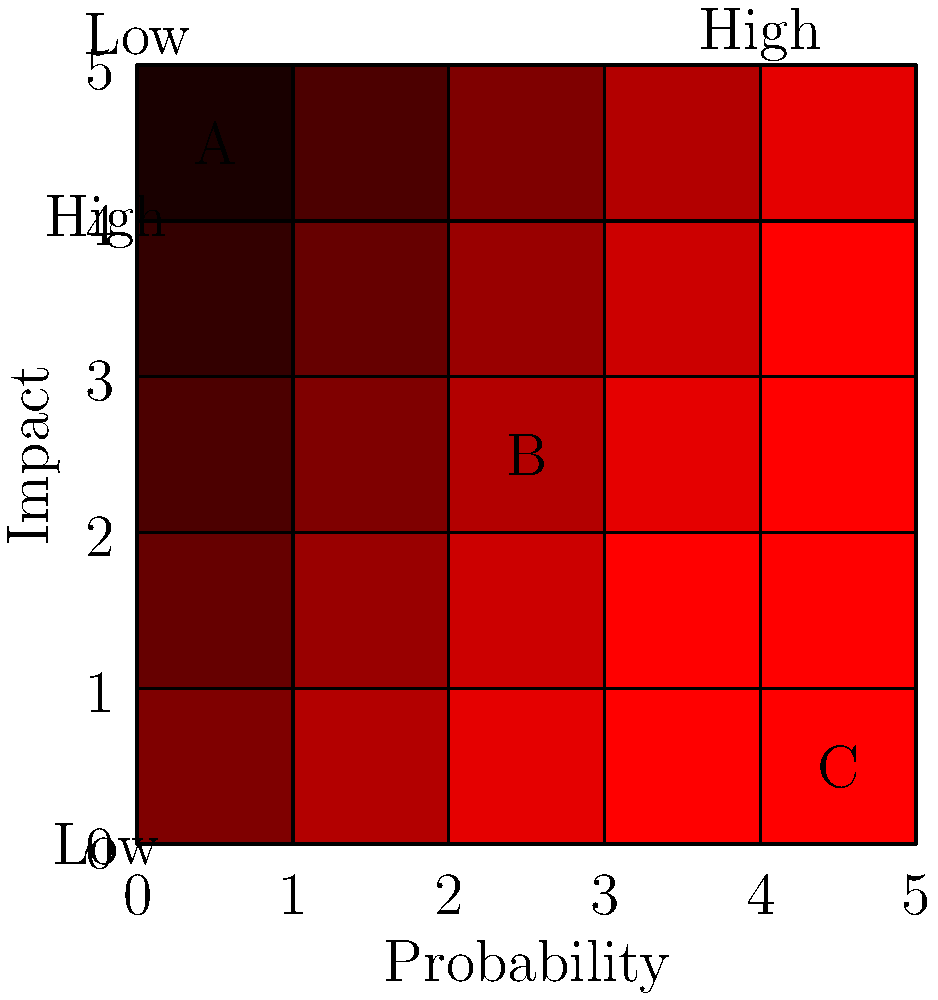As a project manager, you've been tasked with evaluating potential risks and opportunities for a new cost-effective solution. Given the risk matrix above, which of the identified items (A, B, or C) should be prioritized for immediate action to ensure project success without compromising performance? To evaluate the risk matrix and prioritize potential project threats and opportunities, we need to follow these steps:

1. Understand the matrix: The x-axis represents probability (increasing from left to right), and the y-axis represents impact (increasing from bottom to top).

2. Identify the color coding: The darker red areas indicate higher risk or higher priority opportunities.

3. Locate the positions of A, B, and C:
   A: High impact, low probability
   B: Medium impact, medium probability
   C: Low impact, high probability

4. Evaluate each item:
   A: High impact but low probability suggests a significant threat/opportunity that's unlikely to occur.
   B: Medium impact and probability indicate a moderate risk/opportunity.
   C: High probability but low impact suggests a likely event with minimal consequences.

5. Consider the business owner's perspective: As a cost-effective solution is desired without compromising performance, we should prioritize items that could significantly impact the project's success or failure.

6. Prioritize based on the risk level:
   A is in the darkest red zone, indicating the highest risk/opportunity level.
   B is in a medium red zone, suggesting moderate risk/opportunity.
   C is in a lighter red zone, indicating lower risk/opportunity.

7. Make a decision: Item A should be prioritized for immediate action as it has the potential for the most significant impact on the project's success or failure, even though its probability is low.
Answer: A 